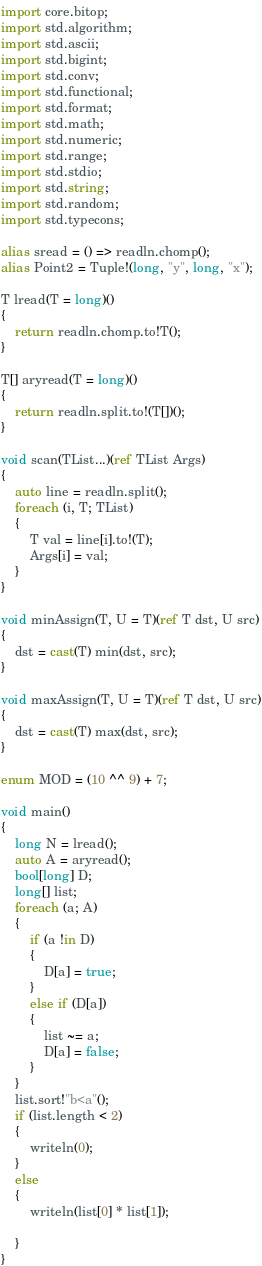<code> <loc_0><loc_0><loc_500><loc_500><_D_>import core.bitop;
import std.algorithm;
import std.ascii;
import std.bigint;
import std.conv;
import std.functional;
import std.format;
import std.math;
import std.numeric;
import std.range;
import std.stdio;
import std.string;
import std.random;
import std.typecons;

alias sread = () => readln.chomp();
alias Point2 = Tuple!(long, "y", long, "x");

T lread(T = long)()
{
    return readln.chomp.to!T();
}

T[] aryread(T = long)()
{
    return readln.split.to!(T[])();
}

void scan(TList...)(ref TList Args)
{
    auto line = readln.split();
    foreach (i, T; TList)
    {
        T val = line[i].to!(T);
        Args[i] = val;
    }
}

void minAssign(T, U = T)(ref T dst, U src)
{
    dst = cast(T) min(dst, src);
}

void maxAssign(T, U = T)(ref T dst, U src)
{
    dst = cast(T) max(dst, src);
}

enum MOD = (10 ^^ 9) + 7;

void main()
{
    long N = lread();
    auto A = aryread();
    bool[long] D;
    long[] list;
    foreach (a; A)
    {
        if (a !in D)
        {
            D[a] = true;
        }
        else if (D[a])
        {
            list ~= a;
            D[a] = false;
        }
    }
    list.sort!"b<a"();
    if (list.length < 2)
    {
        writeln(0);
    }
    else
    {
        writeln(list[0] * list[1]);

    }
}
</code> 